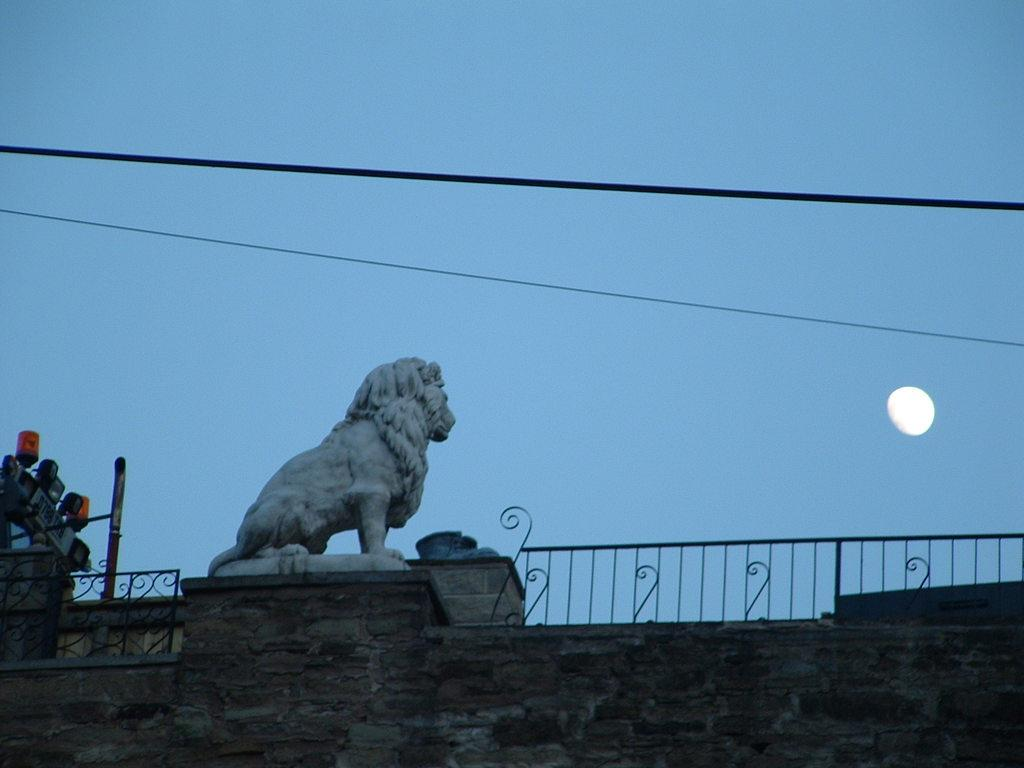What is present on the wall in the image? There is a sculpture on the wall in the image. What type of barrier can be seen in the image? There is fencing in the image. What celestial body is visible in the sky? The moon is visible in the sky. What is located on the left side of the image? There are objects on the left side of the image. Can you describe the secretary working near the sea in the image? There is no secretary or sea present in the image. What type of ornament is hanging from the sculpture on the wall? There is no ornament mentioned or visible in the image. 